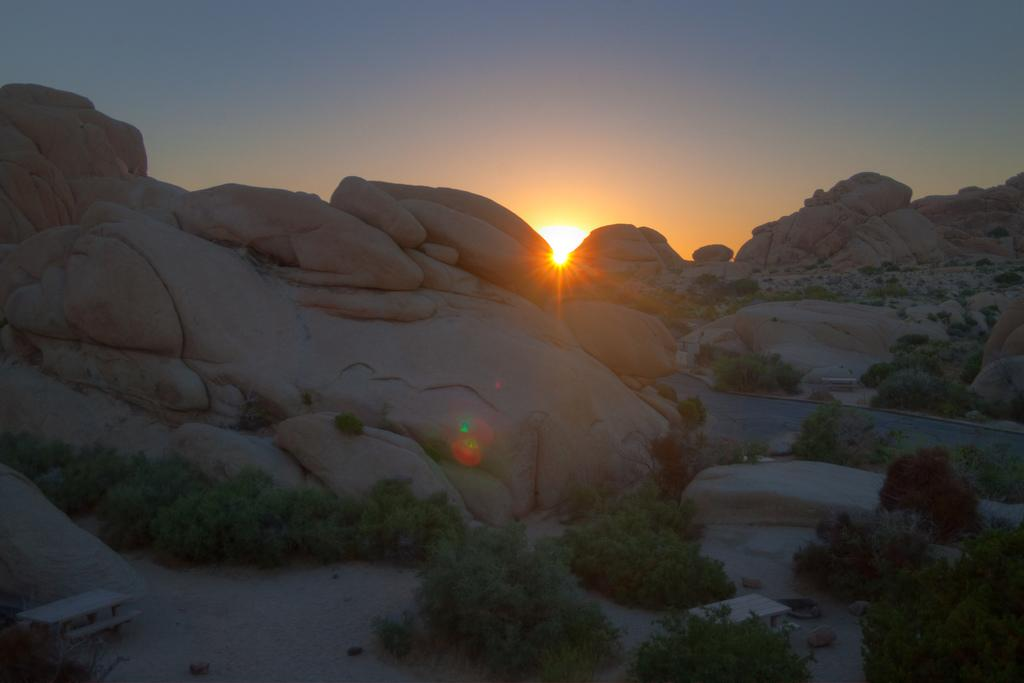What is the main subject of the image? The image depicts a hill. What can be seen in the foreground of the image? There are plants in the foreground of the image. Are there any structures or objects on the hill? Yes, there are benches on the hill. What is visible at the top of the hill? The sky is visible at the top of the hill. What is the condition of the sky in the image? The sun is present in the sky. How many potatoes can be seen growing on the hill in the image? There are no potatoes visible in the image; it depicts a hill with plants, benches, and a sky with the sun. What type of mother is sitting on the bench in the image? There is no mother or person sitting on the bench in the image; it only shows benches on the hill. 